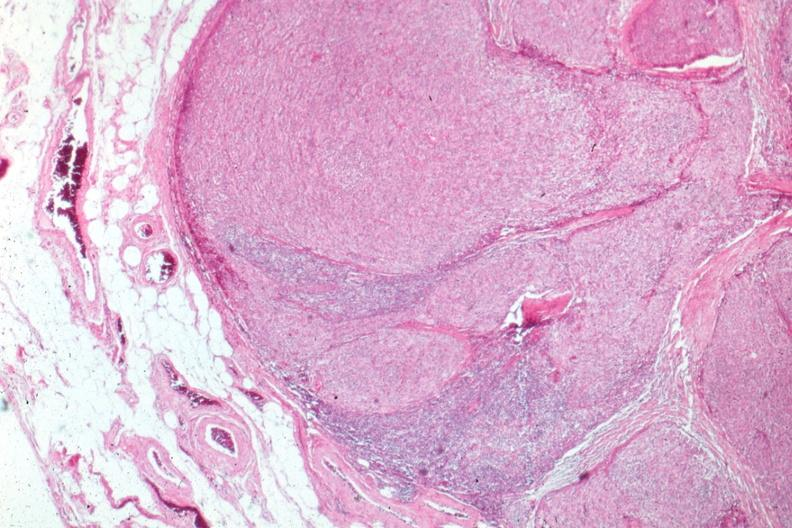s thymoma present?
Answer the question using a single word or phrase. Yes 